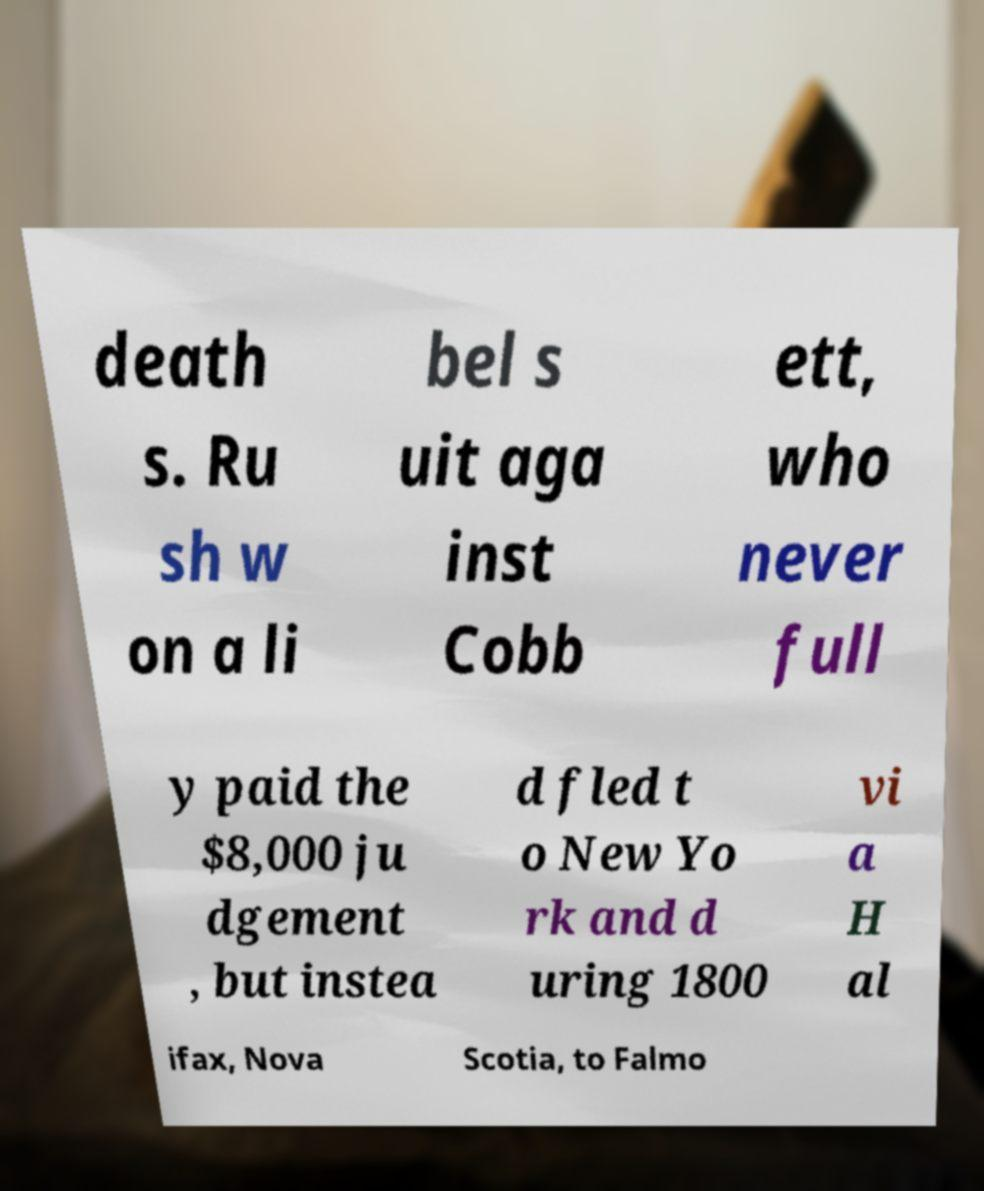Please read and relay the text visible in this image. What does it say? death s. Ru sh w on a li bel s uit aga inst Cobb ett, who never full y paid the $8,000 ju dgement , but instea d fled t o New Yo rk and d uring 1800 vi a H al ifax, Nova Scotia, to Falmo 